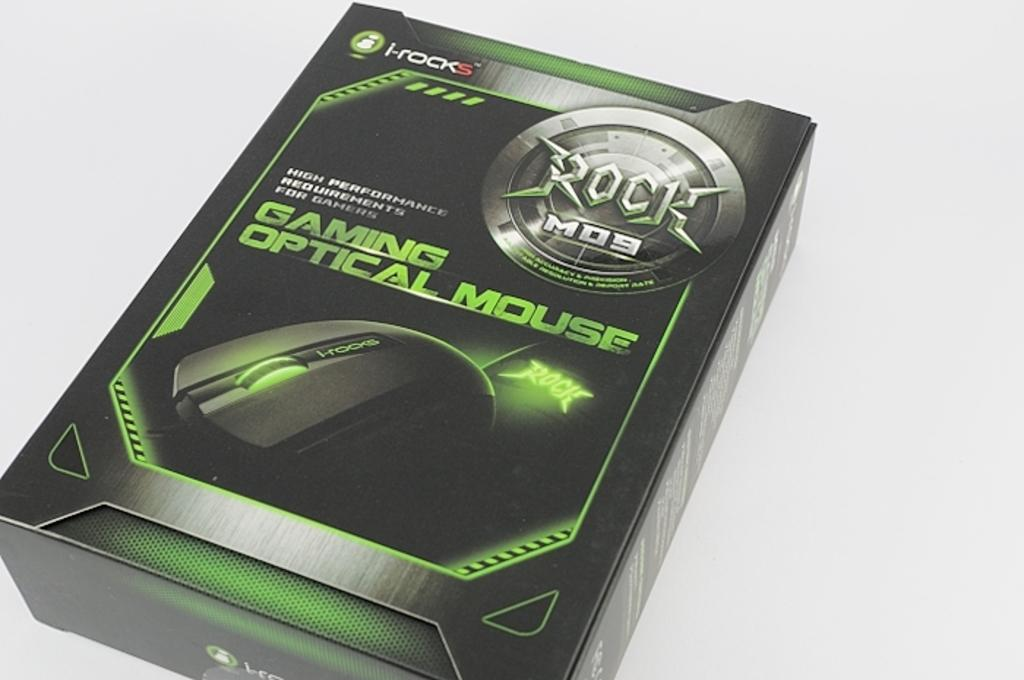What object is present in the image? There is a box in the image. Where is the box located? The box is placed on a white surface. What can be found on the box? There is text and a logo on the box. How many cows are visible in the image? There are no cows present in the image; it features a box on a white surface with text and a logo. 